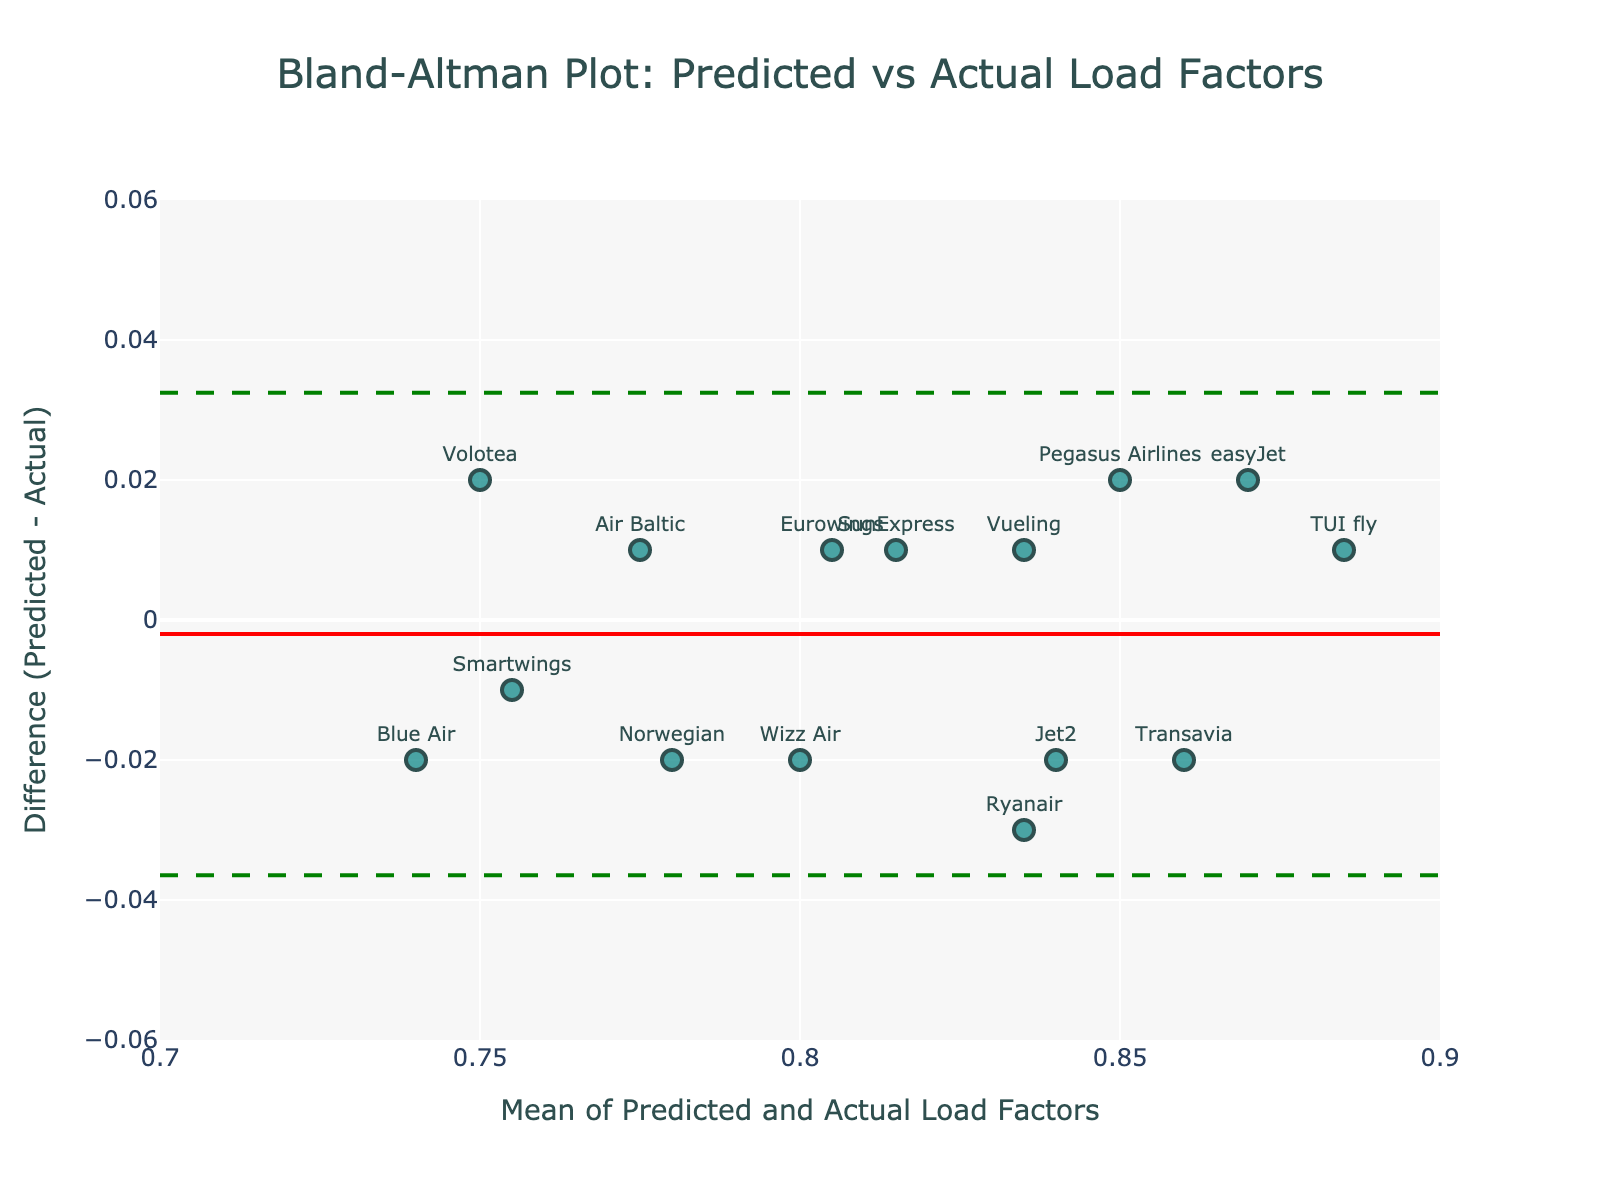How many airlines are included in the plot? By counting the points corresponding to each airline label, there are a total of 15 airlines.
Answer: 15 What's the mean of the differences between the predicted and actual load factors? The mean of the differences is represented by the red horizontal line in the plot.
Answer: 0.00067 What are the limits of agreement (±1.96 SD) for the differences between the predicted and actual load factors? The green dashed lines in the plot represent the upper and lower limits of agreement. The exact values can be read from the plot annotations.
Answer: Upper: 0.033, Lower: -0.0317 Which airline has the largest positive difference between predicted and actual load factors? By observing the scatter points on the plot, the airline with the highest positive difference is Ryanair.
Answer: Ryanair Which airline has the largest negative difference between predicted and actual load factors? By observing the scatter points on the plot, the airline with the largest negative difference is Volotea.
Answer: Volotea How is the difference between predicted and actual load factors distributed around the mean? The differences are distributed relatively evenly around the mean line, indicating a good agreement without systemic bias.
Answer: Evenly around the mean What would be an upper threshold of acceptable difference according to the 1.96 SD rule? The upper limit of agreement line in green indicates the upper threshold.
Answer: 0.033 Which airline falls closest to the mean difference? By looking at which point is closest to the red mean line, Eurowings falls closest to the mean difference.
Answer: Eurowings What's the range of means for the predicted and actual load factors? By observing the x-axis which represents the mean of the predicted and actual load factors, the range spans from 0.735 to 0.885.
Answer: 0.735 to 0.885 Is there any evident systemic bias in the predictions based on the Bland-Altman plot? Since the data points are scattered fairly symmetrically around the mean difference line, there does not appear to be any evident systemic bias.
Answer: No systemic bias 